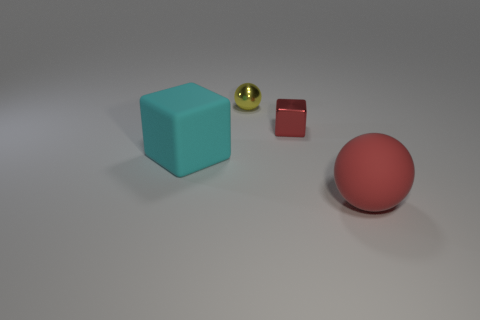Do the red thing in front of the red metal cube and the thing that is to the left of the yellow metal thing have the same shape?
Your answer should be compact. No. What shape is the red shiny object that is the same size as the yellow metal sphere?
Your response must be concise. Cube. How many metallic things are big spheres or blocks?
Keep it short and to the point. 1. Is the material of the red thing that is behind the big matte block the same as the large object that is in front of the cyan cube?
Provide a short and direct response. No. What is the color of the large cube that is the same material as the large red sphere?
Your answer should be very brief. Cyan. Are there more rubber blocks that are right of the red block than large matte things that are behind the tiny yellow metal ball?
Keep it short and to the point. No. Is there a blue rubber block?
Give a very brief answer. No. There is a ball that is the same color as the metal block; what is its material?
Give a very brief answer. Rubber. What number of things are yellow metal objects or matte objects?
Give a very brief answer. 3. Are there any other rubber blocks that have the same color as the large rubber block?
Ensure brevity in your answer.  No. 